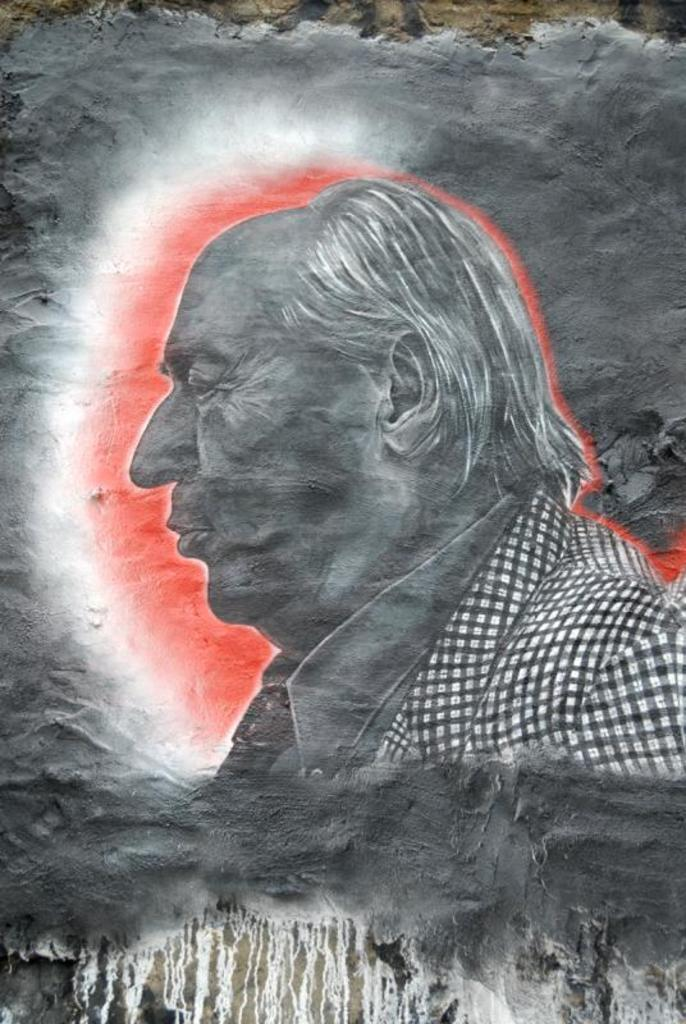What is depicted in the image? There is a painting in the image. What is the subject of the painting? The painting is of a person. Where is the painting located? The painting is on a wall. What type of prose is being recited by the person in the painting? The image does not depict a person reciting prose; it is a painting of a person. 